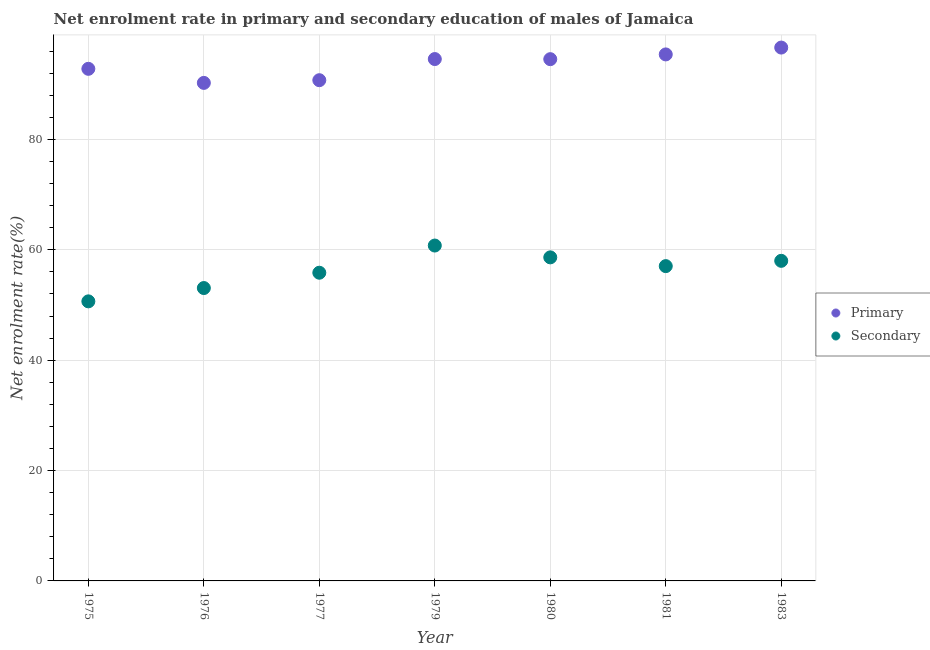How many different coloured dotlines are there?
Your answer should be very brief. 2. What is the enrollment rate in primary education in 1975?
Ensure brevity in your answer.  92.79. Across all years, what is the maximum enrollment rate in primary education?
Offer a very short reply. 96.65. Across all years, what is the minimum enrollment rate in primary education?
Keep it short and to the point. 90.25. In which year was the enrollment rate in secondary education maximum?
Keep it short and to the point. 1979. In which year was the enrollment rate in primary education minimum?
Make the answer very short. 1976. What is the total enrollment rate in primary education in the graph?
Give a very brief answer. 654.93. What is the difference between the enrollment rate in primary education in 1976 and that in 1983?
Provide a succinct answer. -6.4. What is the difference between the enrollment rate in primary education in 1980 and the enrollment rate in secondary education in 1977?
Your answer should be very brief. 38.7. What is the average enrollment rate in secondary education per year?
Provide a short and direct response. 56.29. In the year 1975, what is the difference between the enrollment rate in secondary education and enrollment rate in primary education?
Your answer should be very brief. -42.14. In how many years, is the enrollment rate in primary education greater than 32 %?
Ensure brevity in your answer.  7. What is the ratio of the enrollment rate in primary education in 1975 to that in 1979?
Your answer should be compact. 0.98. Is the enrollment rate in secondary education in 1976 less than that in 1983?
Make the answer very short. Yes. Is the difference between the enrollment rate in primary education in 1976 and 1981 greater than the difference between the enrollment rate in secondary education in 1976 and 1981?
Your answer should be very brief. No. What is the difference between the highest and the second highest enrollment rate in secondary education?
Your response must be concise. 2.14. What is the difference between the highest and the lowest enrollment rate in primary education?
Provide a short and direct response. 6.4. In how many years, is the enrollment rate in primary education greater than the average enrollment rate in primary education taken over all years?
Provide a short and direct response. 4. How many dotlines are there?
Your response must be concise. 2. What is the difference between two consecutive major ticks on the Y-axis?
Ensure brevity in your answer.  20. Are the values on the major ticks of Y-axis written in scientific E-notation?
Make the answer very short. No. Where does the legend appear in the graph?
Your answer should be compact. Center right. What is the title of the graph?
Your answer should be very brief. Net enrolment rate in primary and secondary education of males of Jamaica. What is the label or title of the X-axis?
Keep it short and to the point. Year. What is the label or title of the Y-axis?
Keep it short and to the point. Net enrolment rate(%). What is the Net enrolment rate(%) in Primary in 1975?
Make the answer very short. 92.79. What is the Net enrolment rate(%) in Secondary in 1975?
Ensure brevity in your answer.  50.66. What is the Net enrolment rate(%) in Primary in 1976?
Provide a succinct answer. 90.25. What is the Net enrolment rate(%) in Secondary in 1976?
Your answer should be compact. 53.07. What is the Net enrolment rate(%) of Primary in 1977?
Provide a succinct answer. 90.73. What is the Net enrolment rate(%) of Secondary in 1977?
Ensure brevity in your answer.  55.85. What is the Net enrolment rate(%) of Primary in 1979?
Ensure brevity in your answer.  94.56. What is the Net enrolment rate(%) of Secondary in 1979?
Provide a short and direct response. 60.77. What is the Net enrolment rate(%) of Primary in 1980?
Provide a short and direct response. 94.54. What is the Net enrolment rate(%) in Secondary in 1980?
Ensure brevity in your answer.  58.63. What is the Net enrolment rate(%) in Primary in 1981?
Give a very brief answer. 95.4. What is the Net enrolment rate(%) of Secondary in 1981?
Ensure brevity in your answer.  57.04. What is the Net enrolment rate(%) of Primary in 1983?
Ensure brevity in your answer.  96.65. What is the Net enrolment rate(%) in Secondary in 1983?
Provide a succinct answer. 58. Across all years, what is the maximum Net enrolment rate(%) in Primary?
Your answer should be very brief. 96.65. Across all years, what is the maximum Net enrolment rate(%) in Secondary?
Ensure brevity in your answer.  60.77. Across all years, what is the minimum Net enrolment rate(%) of Primary?
Your response must be concise. 90.25. Across all years, what is the minimum Net enrolment rate(%) in Secondary?
Make the answer very short. 50.66. What is the total Net enrolment rate(%) in Primary in the graph?
Your answer should be very brief. 654.93. What is the total Net enrolment rate(%) of Secondary in the graph?
Provide a succinct answer. 394.02. What is the difference between the Net enrolment rate(%) of Primary in 1975 and that in 1976?
Provide a succinct answer. 2.55. What is the difference between the Net enrolment rate(%) in Secondary in 1975 and that in 1976?
Your response must be concise. -2.41. What is the difference between the Net enrolment rate(%) in Primary in 1975 and that in 1977?
Offer a terse response. 2.06. What is the difference between the Net enrolment rate(%) of Secondary in 1975 and that in 1977?
Offer a terse response. -5.19. What is the difference between the Net enrolment rate(%) of Primary in 1975 and that in 1979?
Offer a terse response. -1.77. What is the difference between the Net enrolment rate(%) in Secondary in 1975 and that in 1979?
Keep it short and to the point. -10.11. What is the difference between the Net enrolment rate(%) of Primary in 1975 and that in 1980?
Offer a very short reply. -1.75. What is the difference between the Net enrolment rate(%) of Secondary in 1975 and that in 1980?
Your answer should be very brief. -7.97. What is the difference between the Net enrolment rate(%) of Primary in 1975 and that in 1981?
Provide a short and direct response. -2.61. What is the difference between the Net enrolment rate(%) of Secondary in 1975 and that in 1981?
Your answer should be compact. -6.38. What is the difference between the Net enrolment rate(%) of Primary in 1975 and that in 1983?
Provide a succinct answer. -3.85. What is the difference between the Net enrolment rate(%) in Secondary in 1975 and that in 1983?
Make the answer very short. -7.34. What is the difference between the Net enrolment rate(%) in Primary in 1976 and that in 1977?
Ensure brevity in your answer.  -0.49. What is the difference between the Net enrolment rate(%) of Secondary in 1976 and that in 1977?
Give a very brief answer. -2.78. What is the difference between the Net enrolment rate(%) in Primary in 1976 and that in 1979?
Keep it short and to the point. -4.32. What is the difference between the Net enrolment rate(%) of Secondary in 1976 and that in 1979?
Keep it short and to the point. -7.7. What is the difference between the Net enrolment rate(%) of Primary in 1976 and that in 1980?
Make the answer very short. -4.3. What is the difference between the Net enrolment rate(%) in Secondary in 1976 and that in 1980?
Ensure brevity in your answer.  -5.56. What is the difference between the Net enrolment rate(%) of Primary in 1976 and that in 1981?
Provide a short and direct response. -5.16. What is the difference between the Net enrolment rate(%) of Secondary in 1976 and that in 1981?
Make the answer very short. -3.97. What is the difference between the Net enrolment rate(%) in Primary in 1976 and that in 1983?
Your response must be concise. -6.4. What is the difference between the Net enrolment rate(%) of Secondary in 1976 and that in 1983?
Offer a very short reply. -4.93. What is the difference between the Net enrolment rate(%) in Primary in 1977 and that in 1979?
Provide a short and direct response. -3.83. What is the difference between the Net enrolment rate(%) of Secondary in 1977 and that in 1979?
Provide a short and direct response. -4.93. What is the difference between the Net enrolment rate(%) of Primary in 1977 and that in 1980?
Your answer should be very brief. -3.81. What is the difference between the Net enrolment rate(%) in Secondary in 1977 and that in 1980?
Make the answer very short. -2.78. What is the difference between the Net enrolment rate(%) of Primary in 1977 and that in 1981?
Make the answer very short. -4.67. What is the difference between the Net enrolment rate(%) in Secondary in 1977 and that in 1981?
Make the answer very short. -1.2. What is the difference between the Net enrolment rate(%) of Primary in 1977 and that in 1983?
Ensure brevity in your answer.  -5.91. What is the difference between the Net enrolment rate(%) in Secondary in 1977 and that in 1983?
Offer a very short reply. -2.16. What is the difference between the Net enrolment rate(%) of Primary in 1979 and that in 1980?
Your answer should be very brief. 0.02. What is the difference between the Net enrolment rate(%) of Secondary in 1979 and that in 1980?
Your answer should be compact. 2.14. What is the difference between the Net enrolment rate(%) in Primary in 1979 and that in 1981?
Your answer should be very brief. -0.84. What is the difference between the Net enrolment rate(%) of Secondary in 1979 and that in 1981?
Offer a terse response. 3.73. What is the difference between the Net enrolment rate(%) of Primary in 1979 and that in 1983?
Your answer should be compact. -2.08. What is the difference between the Net enrolment rate(%) in Secondary in 1979 and that in 1983?
Your response must be concise. 2.77. What is the difference between the Net enrolment rate(%) of Primary in 1980 and that in 1981?
Keep it short and to the point. -0.86. What is the difference between the Net enrolment rate(%) of Secondary in 1980 and that in 1981?
Your answer should be very brief. 1.59. What is the difference between the Net enrolment rate(%) of Primary in 1980 and that in 1983?
Offer a very short reply. -2.1. What is the difference between the Net enrolment rate(%) in Secondary in 1980 and that in 1983?
Keep it short and to the point. 0.63. What is the difference between the Net enrolment rate(%) in Primary in 1981 and that in 1983?
Give a very brief answer. -1.24. What is the difference between the Net enrolment rate(%) in Secondary in 1981 and that in 1983?
Your answer should be very brief. -0.96. What is the difference between the Net enrolment rate(%) of Primary in 1975 and the Net enrolment rate(%) of Secondary in 1976?
Make the answer very short. 39.72. What is the difference between the Net enrolment rate(%) in Primary in 1975 and the Net enrolment rate(%) in Secondary in 1977?
Ensure brevity in your answer.  36.95. What is the difference between the Net enrolment rate(%) in Primary in 1975 and the Net enrolment rate(%) in Secondary in 1979?
Offer a very short reply. 32.02. What is the difference between the Net enrolment rate(%) of Primary in 1975 and the Net enrolment rate(%) of Secondary in 1980?
Your answer should be compact. 34.16. What is the difference between the Net enrolment rate(%) of Primary in 1975 and the Net enrolment rate(%) of Secondary in 1981?
Provide a short and direct response. 35.75. What is the difference between the Net enrolment rate(%) of Primary in 1975 and the Net enrolment rate(%) of Secondary in 1983?
Give a very brief answer. 34.79. What is the difference between the Net enrolment rate(%) in Primary in 1976 and the Net enrolment rate(%) in Secondary in 1977?
Your response must be concise. 34.4. What is the difference between the Net enrolment rate(%) in Primary in 1976 and the Net enrolment rate(%) in Secondary in 1979?
Give a very brief answer. 29.47. What is the difference between the Net enrolment rate(%) of Primary in 1976 and the Net enrolment rate(%) of Secondary in 1980?
Give a very brief answer. 31.61. What is the difference between the Net enrolment rate(%) in Primary in 1976 and the Net enrolment rate(%) in Secondary in 1981?
Ensure brevity in your answer.  33.2. What is the difference between the Net enrolment rate(%) in Primary in 1976 and the Net enrolment rate(%) in Secondary in 1983?
Your answer should be compact. 32.24. What is the difference between the Net enrolment rate(%) of Primary in 1977 and the Net enrolment rate(%) of Secondary in 1979?
Give a very brief answer. 29.96. What is the difference between the Net enrolment rate(%) of Primary in 1977 and the Net enrolment rate(%) of Secondary in 1980?
Provide a succinct answer. 32.1. What is the difference between the Net enrolment rate(%) in Primary in 1977 and the Net enrolment rate(%) in Secondary in 1981?
Your answer should be very brief. 33.69. What is the difference between the Net enrolment rate(%) of Primary in 1977 and the Net enrolment rate(%) of Secondary in 1983?
Ensure brevity in your answer.  32.73. What is the difference between the Net enrolment rate(%) of Primary in 1979 and the Net enrolment rate(%) of Secondary in 1980?
Ensure brevity in your answer.  35.93. What is the difference between the Net enrolment rate(%) of Primary in 1979 and the Net enrolment rate(%) of Secondary in 1981?
Your answer should be compact. 37.52. What is the difference between the Net enrolment rate(%) in Primary in 1979 and the Net enrolment rate(%) in Secondary in 1983?
Keep it short and to the point. 36.56. What is the difference between the Net enrolment rate(%) in Primary in 1980 and the Net enrolment rate(%) in Secondary in 1981?
Provide a short and direct response. 37.5. What is the difference between the Net enrolment rate(%) in Primary in 1980 and the Net enrolment rate(%) in Secondary in 1983?
Offer a very short reply. 36.54. What is the difference between the Net enrolment rate(%) of Primary in 1981 and the Net enrolment rate(%) of Secondary in 1983?
Give a very brief answer. 37.4. What is the average Net enrolment rate(%) of Primary per year?
Provide a short and direct response. 93.56. What is the average Net enrolment rate(%) of Secondary per year?
Your response must be concise. 56.29. In the year 1975, what is the difference between the Net enrolment rate(%) of Primary and Net enrolment rate(%) of Secondary?
Make the answer very short. 42.14. In the year 1976, what is the difference between the Net enrolment rate(%) of Primary and Net enrolment rate(%) of Secondary?
Provide a succinct answer. 37.17. In the year 1977, what is the difference between the Net enrolment rate(%) in Primary and Net enrolment rate(%) in Secondary?
Provide a succinct answer. 34.89. In the year 1979, what is the difference between the Net enrolment rate(%) of Primary and Net enrolment rate(%) of Secondary?
Ensure brevity in your answer.  33.79. In the year 1980, what is the difference between the Net enrolment rate(%) in Primary and Net enrolment rate(%) in Secondary?
Keep it short and to the point. 35.91. In the year 1981, what is the difference between the Net enrolment rate(%) in Primary and Net enrolment rate(%) in Secondary?
Provide a succinct answer. 38.36. In the year 1983, what is the difference between the Net enrolment rate(%) in Primary and Net enrolment rate(%) in Secondary?
Offer a terse response. 38.64. What is the ratio of the Net enrolment rate(%) of Primary in 1975 to that in 1976?
Provide a short and direct response. 1.03. What is the ratio of the Net enrolment rate(%) of Secondary in 1975 to that in 1976?
Your response must be concise. 0.95. What is the ratio of the Net enrolment rate(%) of Primary in 1975 to that in 1977?
Give a very brief answer. 1.02. What is the ratio of the Net enrolment rate(%) of Secondary in 1975 to that in 1977?
Your answer should be compact. 0.91. What is the ratio of the Net enrolment rate(%) in Primary in 1975 to that in 1979?
Keep it short and to the point. 0.98. What is the ratio of the Net enrolment rate(%) of Secondary in 1975 to that in 1979?
Provide a short and direct response. 0.83. What is the ratio of the Net enrolment rate(%) in Primary in 1975 to that in 1980?
Give a very brief answer. 0.98. What is the ratio of the Net enrolment rate(%) in Secondary in 1975 to that in 1980?
Offer a very short reply. 0.86. What is the ratio of the Net enrolment rate(%) in Primary in 1975 to that in 1981?
Keep it short and to the point. 0.97. What is the ratio of the Net enrolment rate(%) of Secondary in 1975 to that in 1981?
Your response must be concise. 0.89. What is the ratio of the Net enrolment rate(%) in Primary in 1975 to that in 1983?
Ensure brevity in your answer.  0.96. What is the ratio of the Net enrolment rate(%) in Secondary in 1975 to that in 1983?
Provide a succinct answer. 0.87. What is the ratio of the Net enrolment rate(%) of Secondary in 1976 to that in 1977?
Provide a short and direct response. 0.95. What is the ratio of the Net enrolment rate(%) of Primary in 1976 to that in 1979?
Ensure brevity in your answer.  0.95. What is the ratio of the Net enrolment rate(%) of Secondary in 1976 to that in 1979?
Give a very brief answer. 0.87. What is the ratio of the Net enrolment rate(%) in Primary in 1976 to that in 1980?
Give a very brief answer. 0.95. What is the ratio of the Net enrolment rate(%) of Secondary in 1976 to that in 1980?
Your answer should be compact. 0.91. What is the ratio of the Net enrolment rate(%) of Primary in 1976 to that in 1981?
Give a very brief answer. 0.95. What is the ratio of the Net enrolment rate(%) of Secondary in 1976 to that in 1981?
Your answer should be very brief. 0.93. What is the ratio of the Net enrolment rate(%) in Primary in 1976 to that in 1983?
Ensure brevity in your answer.  0.93. What is the ratio of the Net enrolment rate(%) in Secondary in 1976 to that in 1983?
Your response must be concise. 0.92. What is the ratio of the Net enrolment rate(%) of Primary in 1977 to that in 1979?
Your answer should be very brief. 0.96. What is the ratio of the Net enrolment rate(%) of Secondary in 1977 to that in 1979?
Offer a very short reply. 0.92. What is the ratio of the Net enrolment rate(%) of Primary in 1977 to that in 1980?
Provide a short and direct response. 0.96. What is the ratio of the Net enrolment rate(%) of Secondary in 1977 to that in 1980?
Offer a very short reply. 0.95. What is the ratio of the Net enrolment rate(%) of Primary in 1977 to that in 1981?
Your answer should be compact. 0.95. What is the ratio of the Net enrolment rate(%) of Primary in 1977 to that in 1983?
Give a very brief answer. 0.94. What is the ratio of the Net enrolment rate(%) in Secondary in 1977 to that in 1983?
Offer a terse response. 0.96. What is the ratio of the Net enrolment rate(%) of Primary in 1979 to that in 1980?
Your answer should be very brief. 1. What is the ratio of the Net enrolment rate(%) in Secondary in 1979 to that in 1980?
Your response must be concise. 1.04. What is the ratio of the Net enrolment rate(%) of Primary in 1979 to that in 1981?
Keep it short and to the point. 0.99. What is the ratio of the Net enrolment rate(%) of Secondary in 1979 to that in 1981?
Offer a terse response. 1.07. What is the ratio of the Net enrolment rate(%) of Primary in 1979 to that in 1983?
Provide a succinct answer. 0.98. What is the ratio of the Net enrolment rate(%) of Secondary in 1979 to that in 1983?
Give a very brief answer. 1.05. What is the ratio of the Net enrolment rate(%) of Primary in 1980 to that in 1981?
Provide a succinct answer. 0.99. What is the ratio of the Net enrolment rate(%) of Secondary in 1980 to that in 1981?
Give a very brief answer. 1.03. What is the ratio of the Net enrolment rate(%) of Primary in 1980 to that in 1983?
Offer a terse response. 0.98. What is the ratio of the Net enrolment rate(%) of Secondary in 1980 to that in 1983?
Your answer should be compact. 1.01. What is the ratio of the Net enrolment rate(%) in Primary in 1981 to that in 1983?
Provide a short and direct response. 0.99. What is the ratio of the Net enrolment rate(%) of Secondary in 1981 to that in 1983?
Your response must be concise. 0.98. What is the difference between the highest and the second highest Net enrolment rate(%) in Primary?
Offer a terse response. 1.24. What is the difference between the highest and the second highest Net enrolment rate(%) in Secondary?
Your answer should be very brief. 2.14. What is the difference between the highest and the lowest Net enrolment rate(%) in Primary?
Offer a very short reply. 6.4. What is the difference between the highest and the lowest Net enrolment rate(%) of Secondary?
Provide a short and direct response. 10.11. 